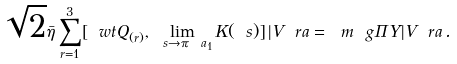<formula> <loc_0><loc_0><loc_500><loc_500>\sqrt { 2 } \bar { \eta } \sum _ { r = 1 } ^ { 3 } [ \ w t { Q } _ { ( r ) } , \lim _ { \ s \to \pi \ a _ { 1 } } K ( \ s ) ] \, | V \ r a = \ m \ g \Pi Y | V \ r a \, .</formula> 